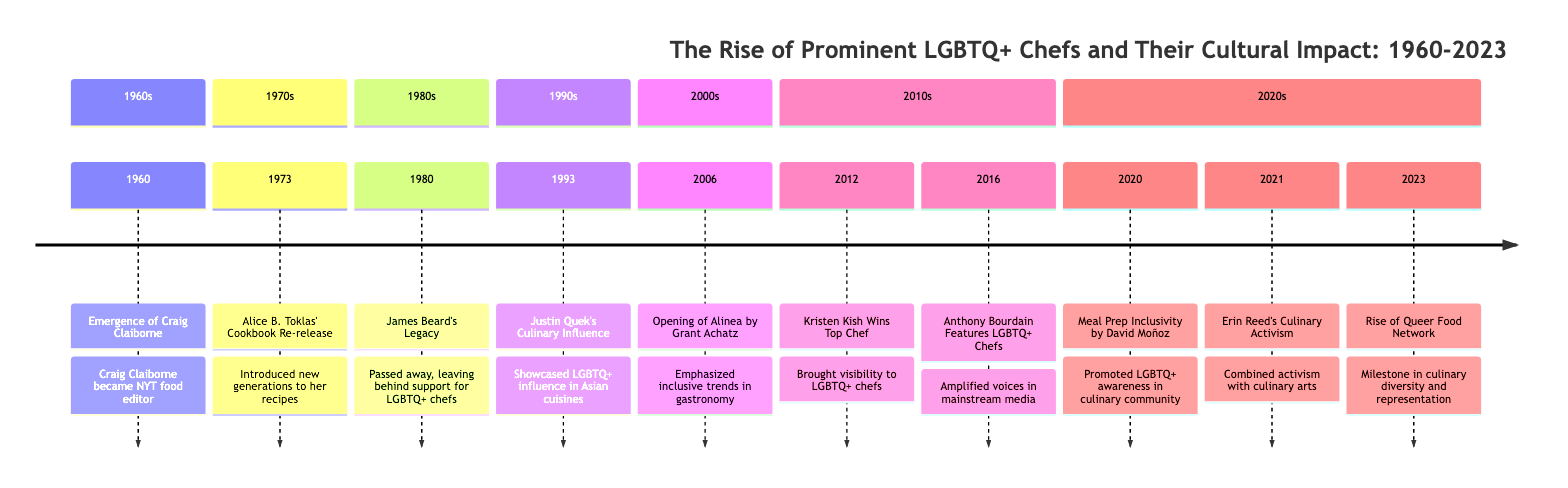What year did Craig Claiborne become the food editor of The New York Times? The timeline indicates that Craig Claiborne's emergence as the food editor took place in 1960.
Answer: 1960 Who was influential in LGBTQ+ culinary culture in 1973? The event from 1973 describes the re-release of Alice B. Toklas' cookbook, highlighting her influence as a partner of Gertrude Stein in the culinary world.
Answer: Alice B. Toklas What significant event took place in the culinary world in 1980? According to the timeline, James Beard passed away in 1980, and it notes his legacy included support for many emerging LGBTQ+ chefs.
Answer: James Beard’s Legacy Which chef was highlighted for their influence in 1993? The entry for 1993 identifies Justin Quek as a Singaporean chef who showcased the influence of LGBTQ+ chefs in Asian and global cuisines.
Answer: Justin Quek How did Kristen Kish contribute to LGBTQ+ chef visibility in 2012? The timeline states her win on 'Top Chef' Season 10, which significantly increased visibility and recognition for LGBTQ+ chefs on a national platform.
Answer: Wins Top Chef What change in media representation occurred in 2016? In 2016, Anthony Bourdain featured and celebrated the stories of LGBTQ+ chefs, indicating a shift in the representation of LGBTQ+ individuals in mainstream media.
Answer: Featured LGBTQ+ Chefs What initiative did David Moñoz begin in 2020? The timeline describes that David Moñoz began initiatives related to meal prep that emphasized inclusivity and promoted LGBTQ+ awareness within the culinary community.
Answer: Meal Prep Inclusivity What was established in 2023 to support LGBTQ+ chefs? The timeline indicates that the Queer Food Network was established in 2023, dedicated to showcasing LGBTQ+ chefs and their culinary achievements.
Answer: Rise of Queer Food Network How many decades does the timeline cover? The timeline spans from 1960 to 2023, covering more than six decades. Thus, the answer is based on counting the years from each marked section.
Answer: Six decades 